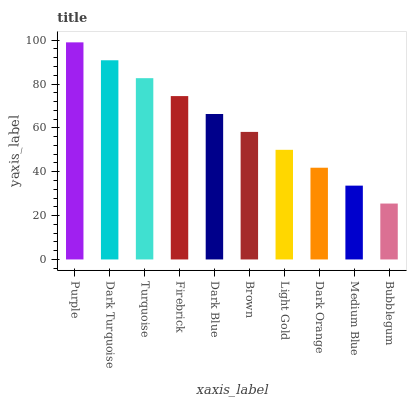Is Bubblegum the minimum?
Answer yes or no. Yes. Is Purple the maximum?
Answer yes or no. Yes. Is Dark Turquoise the minimum?
Answer yes or no. No. Is Dark Turquoise the maximum?
Answer yes or no. No. Is Purple greater than Dark Turquoise?
Answer yes or no. Yes. Is Dark Turquoise less than Purple?
Answer yes or no. Yes. Is Dark Turquoise greater than Purple?
Answer yes or no. No. Is Purple less than Dark Turquoise?
Answer yes or no. No. Is Dark Blue the high median?
Answer yes or no. Yes. Is Brown the low median?
Answer yes or no. Yes. Is Turquoise the high median?
Answer yes or no. No. Is Purple the low median?
Answer yes or no. No. 